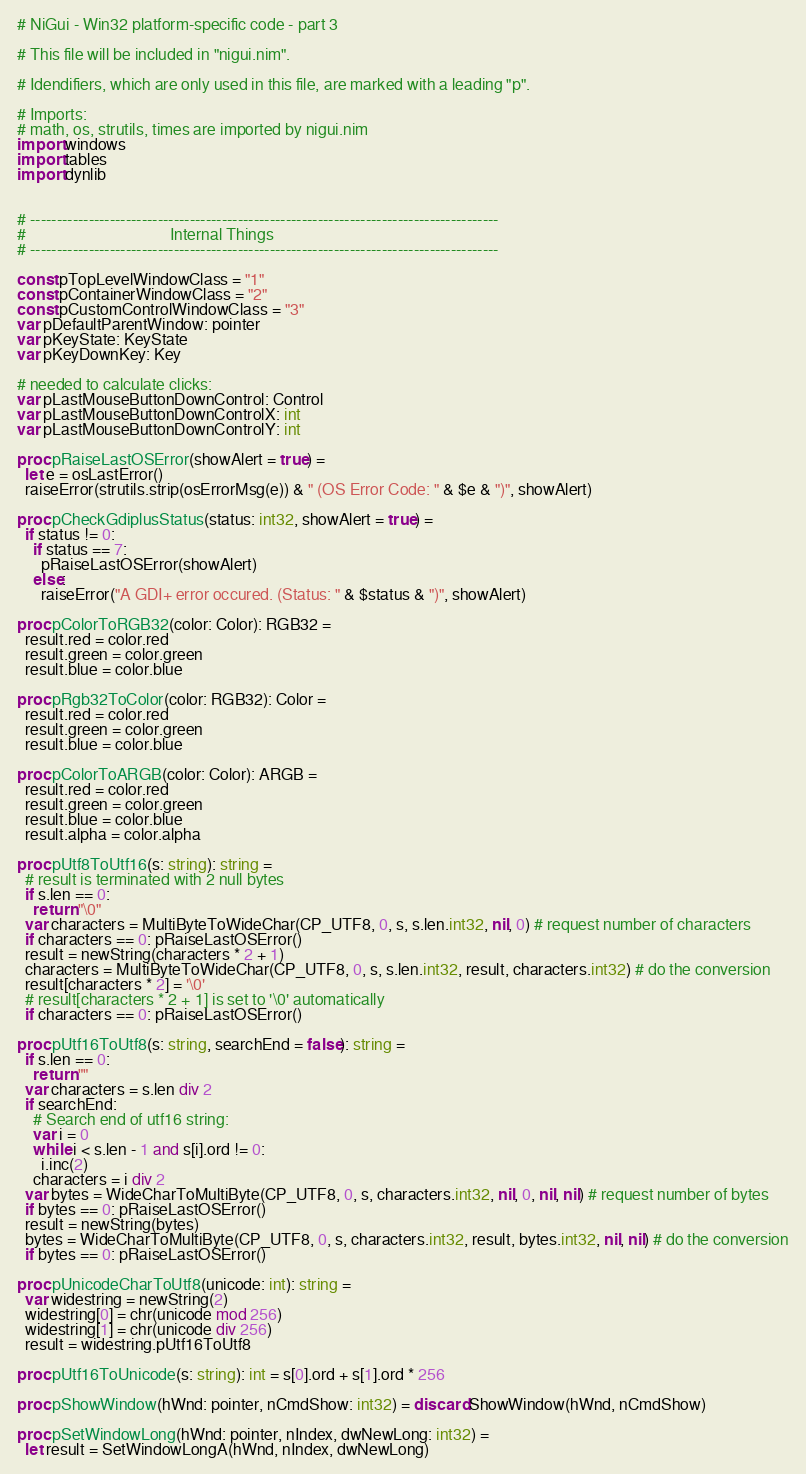Convert code to text. <code><loc_0><loc_0><loc_500><loc_500><_Nim_># NiGui - Win32 platform-specific code - part 3

# This file will be included in "nigui.nim".

# Idendifiers, which are only used in this file, are marked with a leading "p".

# Imports:
# math, os, strutils, times are imported by nigui.nim
import windows
import tables
import dynlib


# ----------------------------------------------------------------------------------------
#                                    Internal Things
# ----------------------------------------------------------------------------------------

const pTopLevelWindowClass = "1"
const pContainerWindowClass = "2"
const pCustomControlWindowClass = "3"
var pDefaultParentWindow: pointer
var pKeyState: KeyState
var pKeyDownKey: Key

# needed to calculate clicks:
var pLastMouseButtonDownControl: Control
var pLastMouseButtonDownControlX: int
var pLastMouseButtonDownControlY: int

proc pRaiseLastOSError(showAlert = true) =
  let e = osLastError()
  raiseError(strutils.strip(osErrorMsg(e)) & " (OS Error Code: " & $e & ")", showAlert)

proc pCheckGdiplusStatus(status: int32, showAlert = true) =
  if status != 0:
    if status == 7:
      pRaiseLastOSError(showAlert)
    else:
      raiseError("A GDI+ error occured. (Status: " & $status & ")", showAlert)

proc pColorToRGB32(color: Color): RGB32 =
  result.red = color.red
  result.green = color.green
  result.blue = color.blue

proc pRgb32ToColor(color: RGB32): Color =
  result.red = color.red
  result.green = color.green
  result.blue = color.blue

proc pColorToARGB(color: Color): ARGB =
  result.red = color.red
  result.green = color.green
  result.blue = color.blue
  result.alpha = color.alpha

proc pUtf8ToUtf16(s: string): string =
  # result is terminated with 2 null bytes
  if s.len == 0:
    return "\0"
  var characters = MultiByteToWideChar(CP_UTF8, 0, s, s.len.int32, nil, 0) # request number of characters
  if characters == 0: pRaiseLastOSError()
  result = newString(characters * 2 + 1)
  characters = MultiByteToWideChar(CP_UTF8, 0, s, s.len.int32, result, characters.int32) # do the conversion
  result[characters * 2] = '\0'
  # result[characters * 2 + 1] is set to '\0' automatically
  if characters == 0: pRaiseLastOSError()

proc pUtf16ToUtf8(s: string, searchEnd = false): string =
  if s.len == 0:
    return ""
  var characters = s.len div 2
  if searchEnd:
    # Search end of utf16 string:
    var i = 0
    while i < s.len - 1 and s[i].ord != 0:
      i.inc(2)
    characters = i div 2
  var bytes = WideCharToMultiByte(CP_UTF8, 0, s, characters.int32, nil, 0, nil, nil) # request number of bytes
  if bytes == 0: pRaiseLastOSError()
  result = newString(bytes)
  bytes = WideCharToMultiByte(CP_UTF8, 0, s, characters.int32, result, bytes.int32, nil, nil) # do the conversion
  if bytes == 0: pRaiseLastOSError()

proc pUnicodeCharToUtf8(unicode: int): string =
  var widestring = newString(2)
  widestring[0] = chr(unicode mod 256)
  widestring[1] = chr(unicode div 256)
  result = widestring.pUtf16ToUtf8

proc pUtf16ToUnicode(s: string): int = s[0].ord + s[1].ord * 256

proc pShowWindow(hWnd: pointer, nCmdShow: int32) = discard ShowWindow(hWnd, nCmdShow)

proc pSetWindowLong(hWnd: pointer, nIndex, dwNewLong: int32) =
  let result = SetWindowLongA(hWnd, nIndex, dwNewLong)</code> 